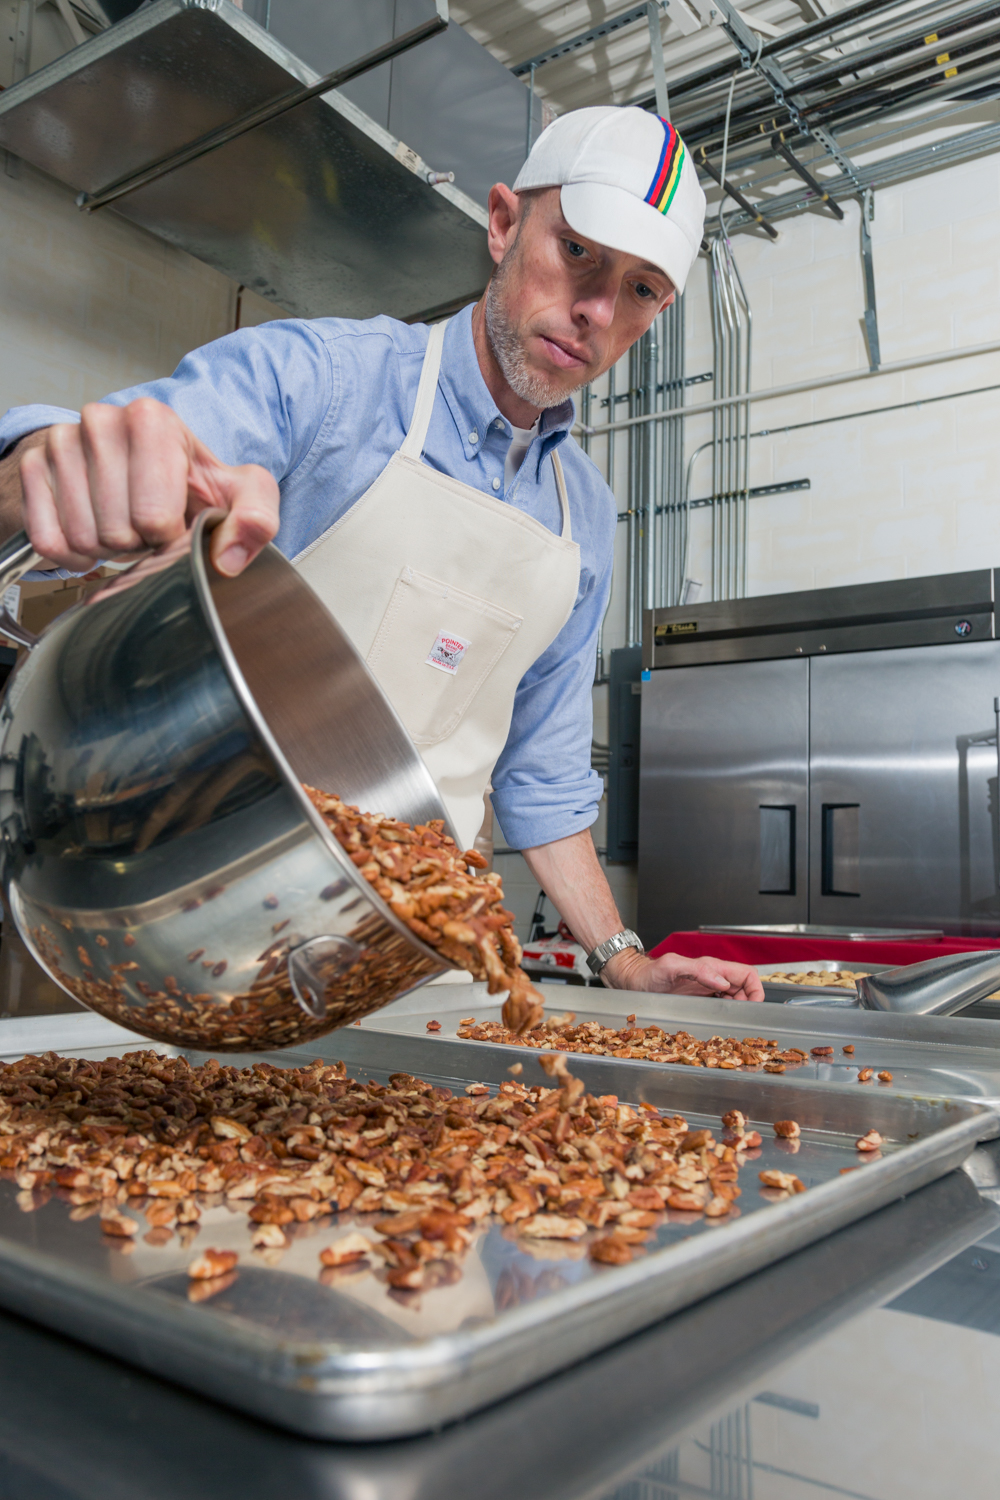Imagine this kitchen as part of a historic mansion turned museum. What might this kitchen's design tell visitors about the culinary history of the era? If this kitchen were part of a historic mansion turned museum, its design could provide visitors with a glimpse into the culinary practices and technologies of the past. The presence of high-end commercial kitchen equipment might indicate the period when such appliances became more widely available and affordable for large households or institutions. The layout and design could also reflect the evolution of kitchen hygiene standards and the role of professional chefs in affluent homes. Exhibits might include historical cooking tools, recipes, and accounts of typical meals prepared in such kitchens, offering a comprehensive view of the culinary culture of the era. What kind of special events or demonstrations could be held in this kitchen to attract museum visitors? Special events or demonstrations that could be held in this kitchen to attract museum visitors might include live cooking demonstrations of traditional recipes, showcasing historical cooking techniques and ingredients. The kitchen could also host workshops on the art of preserving nuts and other ingredients as it was done in the past, allowing visitors to gain hands-on experience. Additionally, thematic culinary events, where guests can sharegpt4v/sample historical dishes and learn about the dietary habits of different time periods, would provide an engaging and educational experience. 